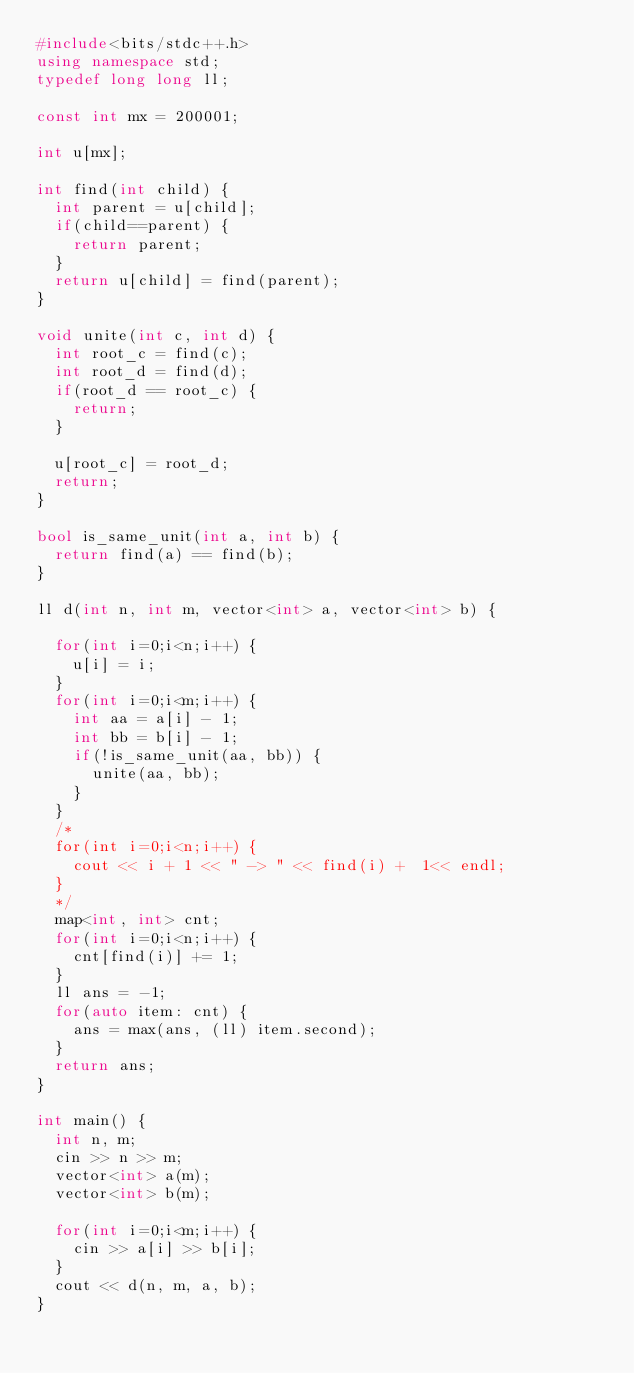<code> <loc_0><loc_0><loc_500><loc_500><_C++_>#include<bits/stdc++.h>
using namespace std;
typedef long long ll;

const int mx = 200001;

int u[mx];

int find(int child) {
  int parent = u[child];
  if(child==parent) {
    return parent;
  }
  return u[child] = find(parent);
}

void unite(int c, int d) {
  int root_c = find(c);
  int root_d = find(d);
  if(root_d == root_c) {
    return;
  }

  u[root_c] = root_d;
  return;
}

bool is_same_unit(int a, int b) {
  return find(a) == find(b);
}

ll d(int n, int m, vector<int> a, vector<int> b) {

  for(int i=0;i<n;i++) {
    u[i] = i;
  }
  for(int i=0;i<m;i++) {
    int aa = a[i] - 1;
    int bb = b[i] - 1;
    if(!is_same_unit(aa, bb)) {
      unite(aa, bb);
    }
  }
  /*
  for(int i=0;i<n;i++) {
    cout << i + 1 << " -> " << find(i) +  1<< endl;
  }
  */
  map<int, int> cnt;
  for(int i=0;i<n;i++) {
    cnt[find(i)] += 1;
  }
  ll ans = -1;
  for(auto item: cnt) {
    ans = max(ans, (ll) item.second);
  }
  return ans;
}

int main() {
  int n, m;
  cin >> n >> m;
  vector<int> a(m);
  vector<int> b(m);

  for(int i=0;i<m;i++) {
    cin >> a[i] >> b[i];
  }
  cout << d(n, m, a, b);
}</code> 